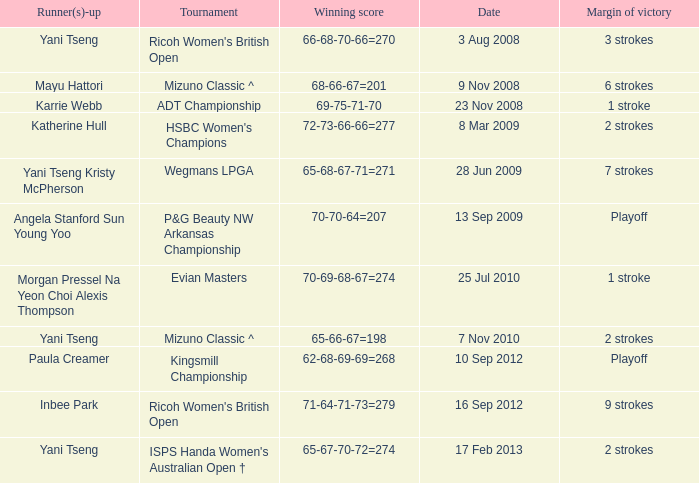What tournament had a victory of a 1 stroke margin and the final winning score 69-75-71-70? ADT Championship. 